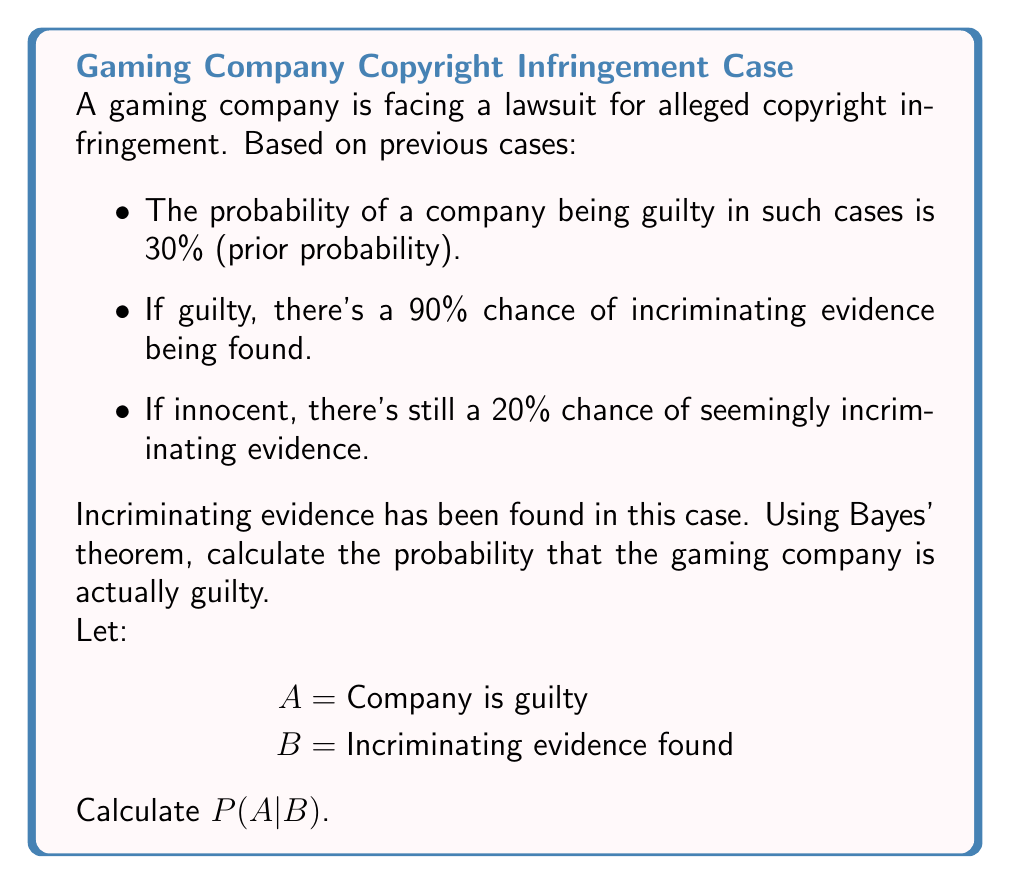Can you solve this math problem? To solve this problem using Bayes' theorem, we'll follow these steps:

1. Identify the given probabilities:
   P(A) = 0.30 (prior probability of guilt)
   P(B|A) = 0.90 (probability of evidence if guilty)
   P(B|not A) = 0.20 (probability of evidence if innocent)

2. Recall Bayes' theorem:
   $$P(A|B) = \frac{P(B|A) \cdot P(A)}{P(B)}$$

3. Calculate P(B) using the law of total probability:
   $$P(B) = P(B|A) \cdot P(A) + P(B|not A) \cdot P(not A)$$
   $$P(B) = 0.90 \cdot 0.30 + 0.20 \cdot (1 - 0.30)$$
   $$P(B) = 0.27 + 0.14 = 0.41$$

4. Apply Bayes' theorem:
   $$P(A|B) = \frac{0.90 \cdot 0.30}{0.41}$$
   $$P(A|B) = \frac{0.27}{0.41} \approx 0.6585$$

5. Convert to percentage:
   0.6585 * 100% ≈ 65.85%
Answer: 65.85% 